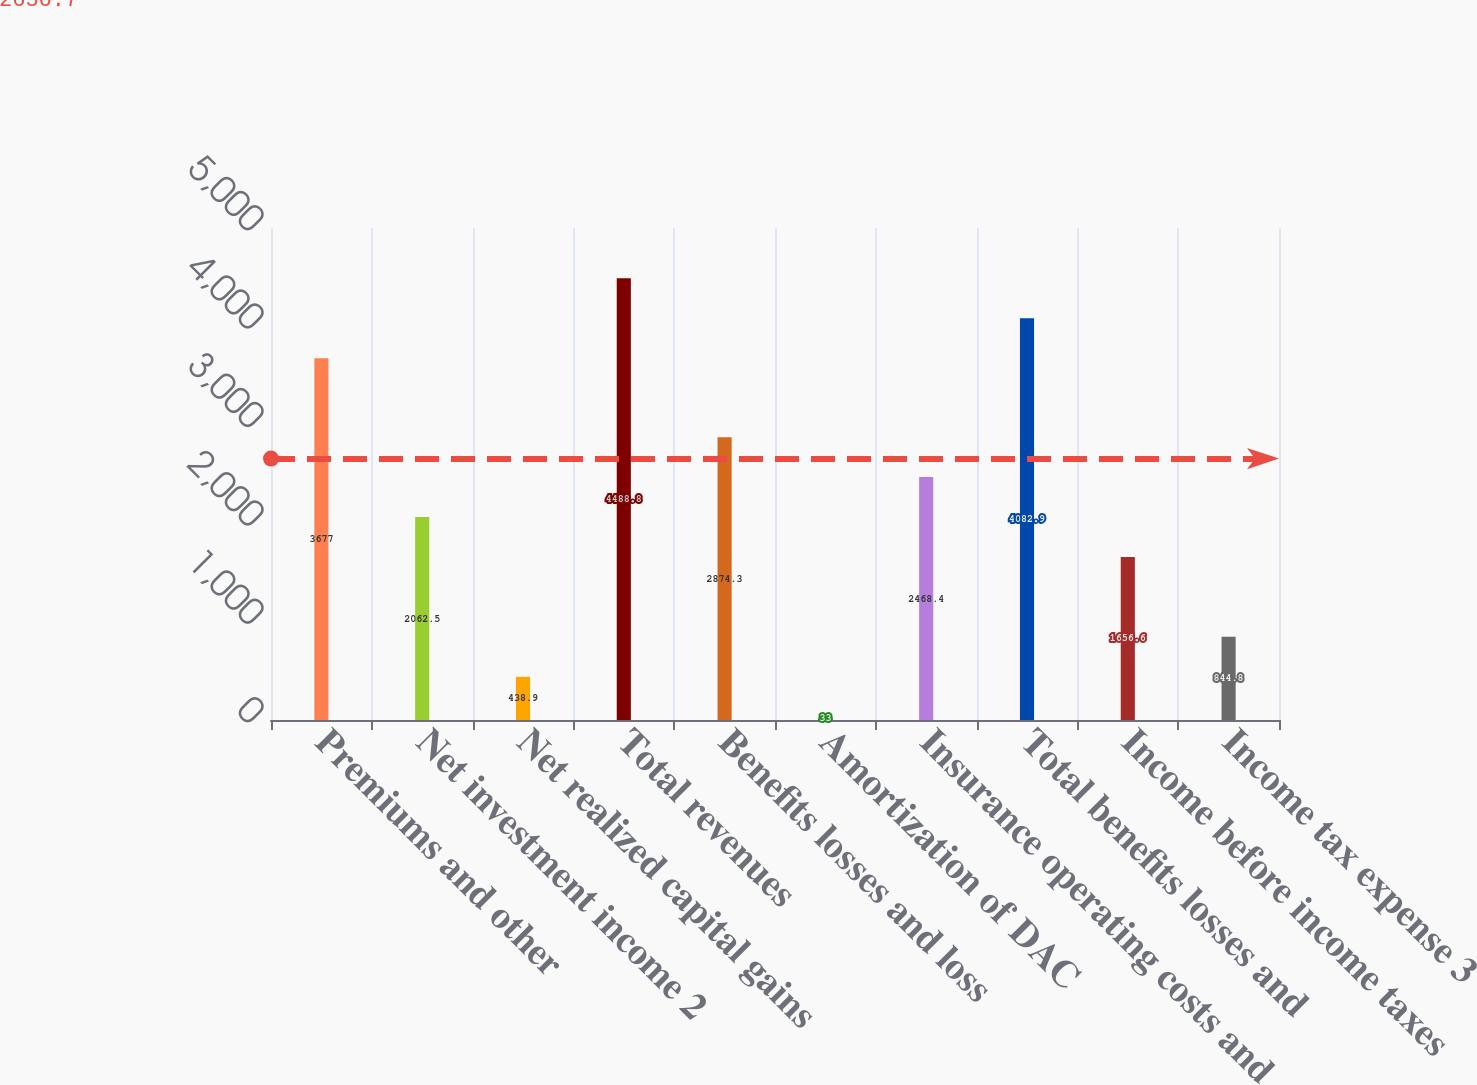Convert chart to OTSL. <chart><loc_0><loc_0><loc_500><loc_500><bar_chart><fcel>Premiums and other<fcel>Net investment income 2<fcel>Net realized capital gains<fcel>Total revenues<fcel>Benefits losses and loss<fcel>Amortization of DAC<fcel>Insurance operating costs and<fcel>Total benefits losses and<fcel>Income before income taxes<fcel>Income tax expense 3<nl><fcel>3677<fcel>2062.5<fcel>438.9<fcel>4488.8<fcel>2874.3<fcel>33<fcel>2468.4<fcel>4082.9<fcel>1656.6<fcel>844.8<nl></chart> 